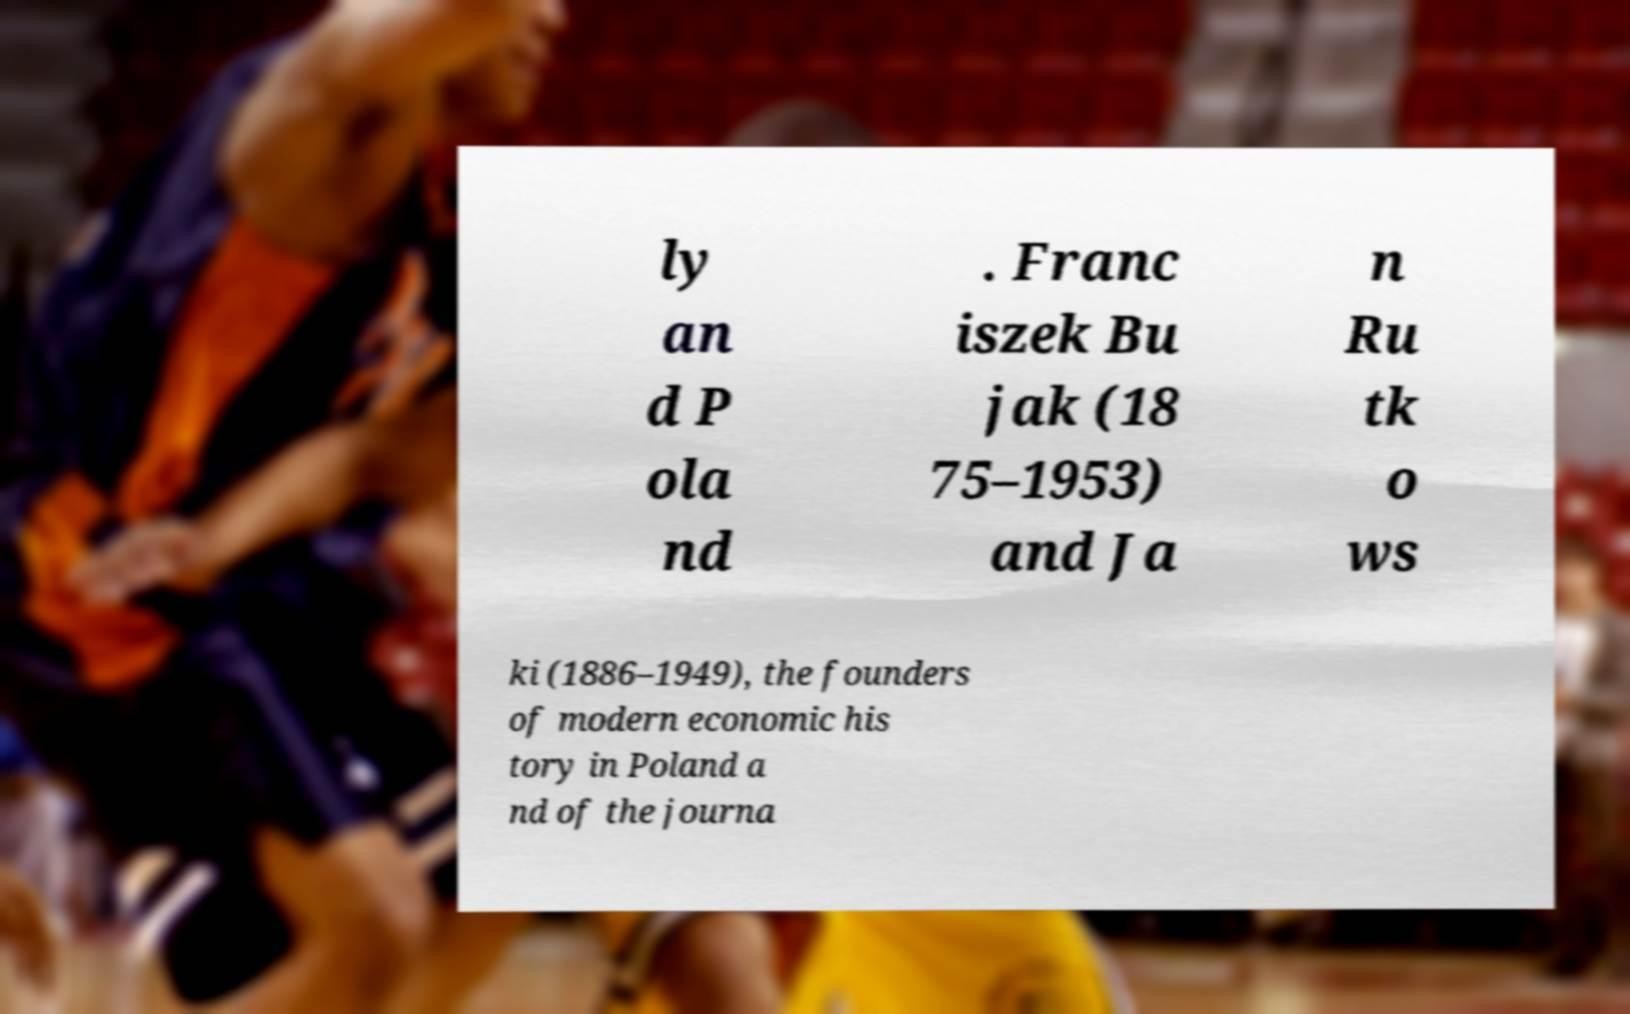Please identify and transcribe the text found in this image. ly an d P ola nd . Franc iszek Bu jak (18 75–1953) and Ja n Ru tk o ws ki (1886–1949), the founders of modern economic his tory in Poland a nd of the journa 